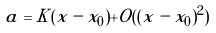<formula> <loc_0><loc_0><loc_500><loc_500>a = K ( x - x _ { 0 } ) + O ( ( x - x _ { 0 } ) ^ { 2 } )</formula> 